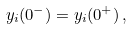Convert formula to latex. <formula><loc_0><loc_0><loc_500><loc_500>y _ { i } ( 0 ^ { - } ) = y _ { i } ( 0 ^ { + } ) \, ,</formula> 